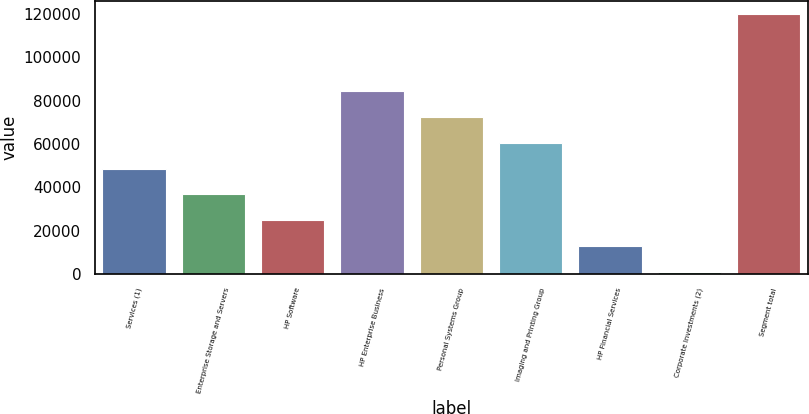Convert chart to OTSL. <chart><loc_0><loc_0><loc_500><loc_500><bar_chart><fcel>Services (1)<fcel>Enterprise Storage and Servers<fcel>HP Software<fcel>HP Enterprise Business<fcel>Personal Systems Group<fcel>Imaging and Printing Group<fcel>HP Financial Services<fcel>Corporate Investments (2)<fcel>Segment total<nl><fcel>48646.6<fcel>36726.2<fcel>24805.8<fcel>84407.8<fcel>72487.4<fcel>60567<fcel>12885.4<fcel>965<fcel>120169<nl></chart> 